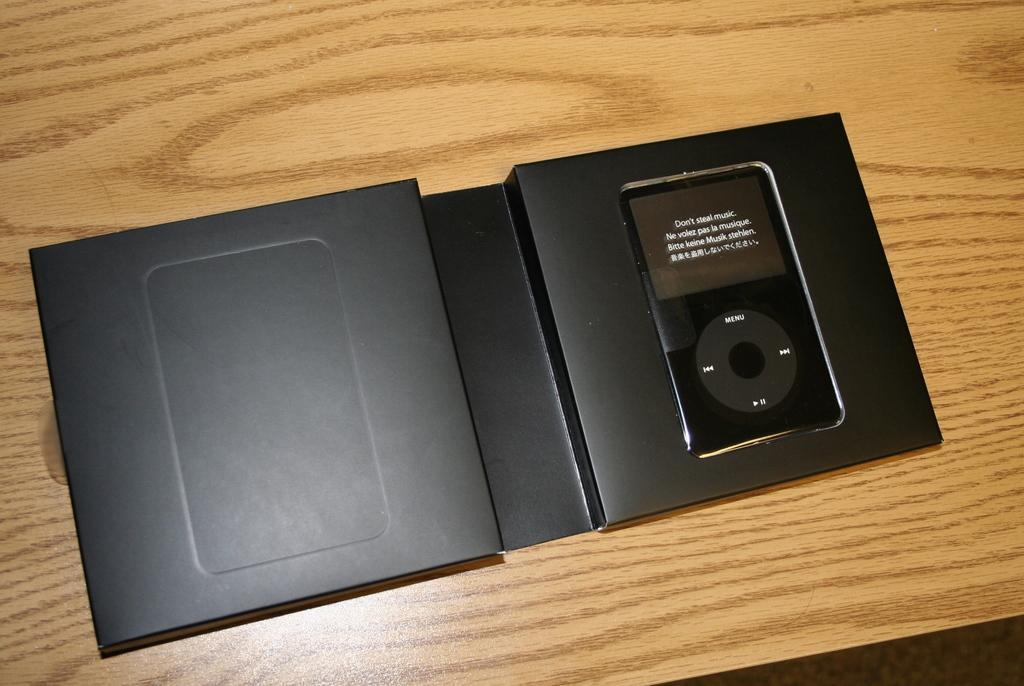What is the color of the object in the image? The object in the image is black. What is displayed on the screen in the image? There is writing on a screen in the image. What is the color of the surface on which the screen is placed? The screen is on a brown surface. How many people are in the crowd behind the black object in the image? There is no crowd present in the image; it only features a black object and a screen with writing. Can you describe the ear of the person in the image? There is no person or ear visible in the image. 